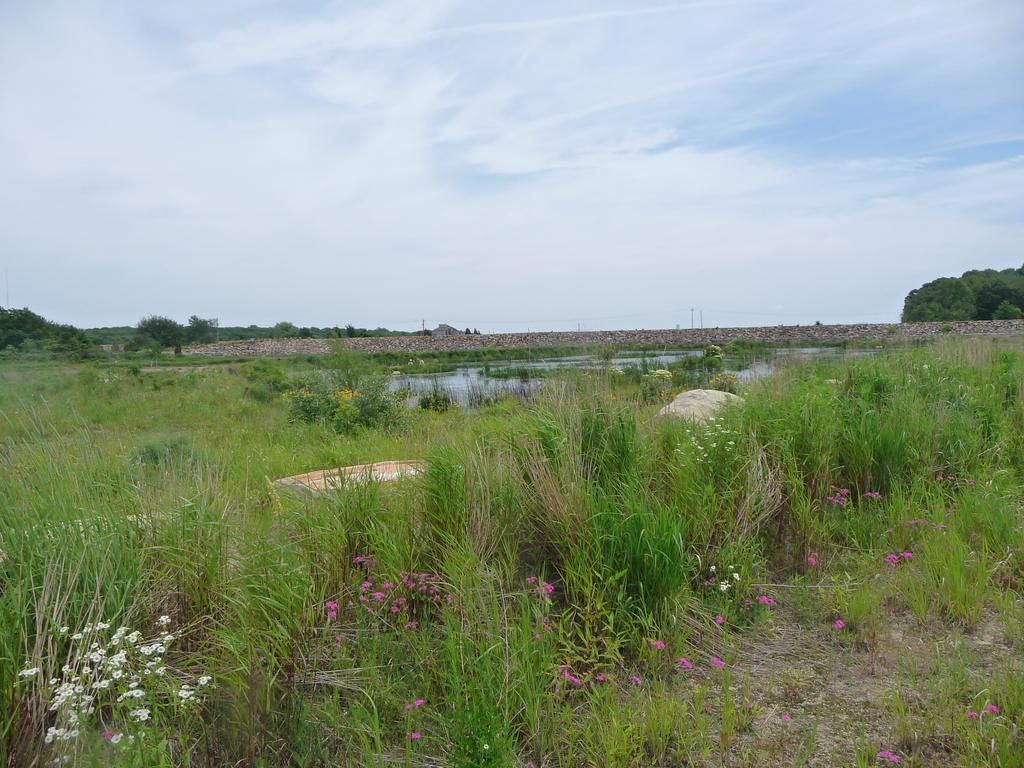In one or two sentences, can you explain what this image depicts? In this picture we can see some Purple and white color flowers in the grassland. Behind we can see small water pound. In the background we can see some stones and trees. 